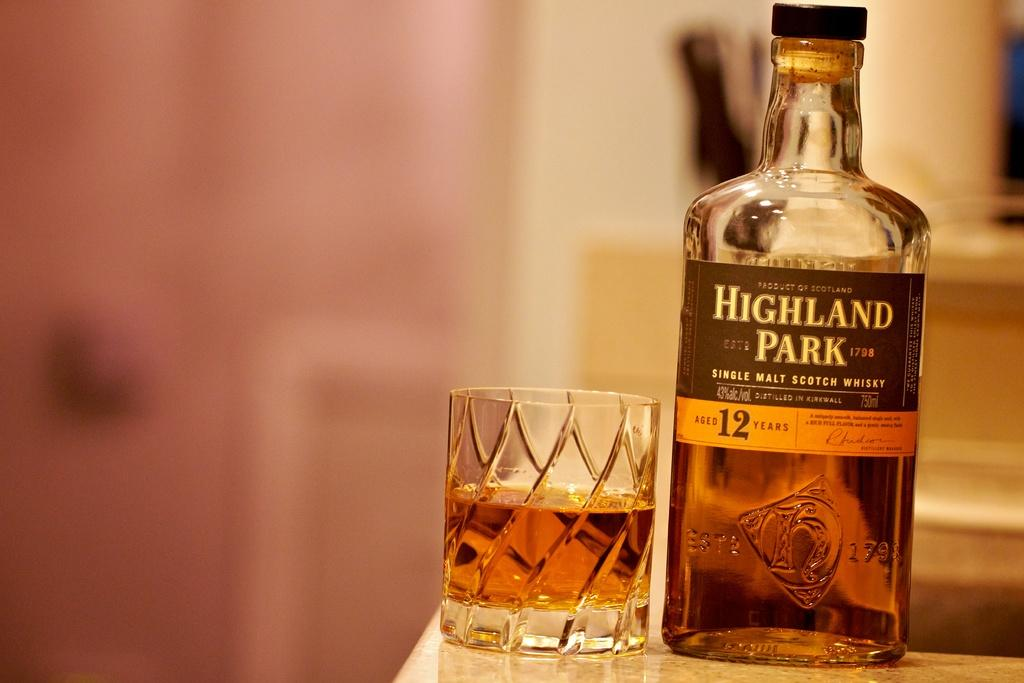Provide a one-sentence caption for the provided image. A bottle of "Highland Park" whisky with the half full highball glass beside it. 